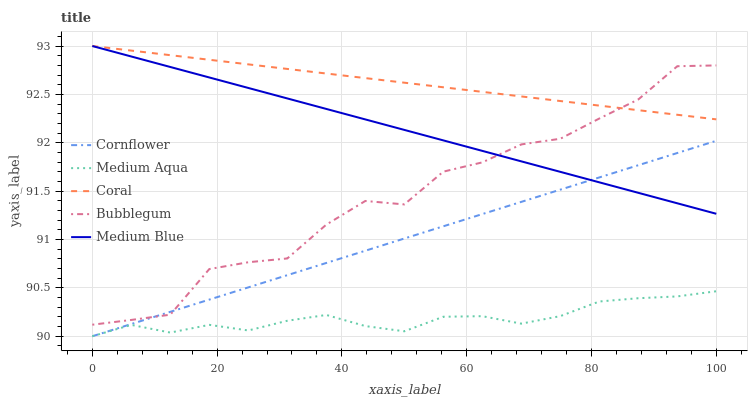Does Coral have the minimum area under the curve?
Answer yes or no. No. Does Medium Aqua have the maximum area under the curve?
Answer yes or no. No. Is Coral the smoothest?
Answer yes or no. No. Is Coral the roughest?
Answer yes or no. No. Does Coral have the lowest value?
Answer yes or no. No. Does Medium Aqua have the highest value?
Answer yes or no. No. Is Cornflower less than Coral?
Answer yes or no. Yes. Is Coral greater than Medium Aqua?
Answer yes or no. Yes. Does Cornflower intersect Coral?
Answer yes or no. No. 